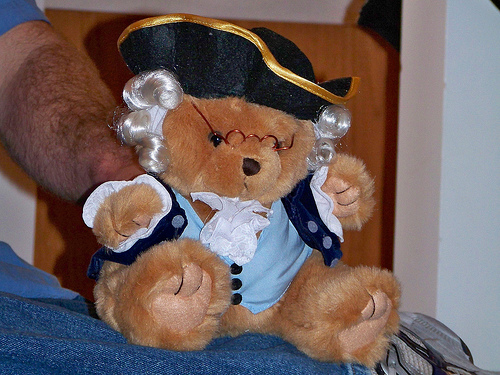<image>
Can you confirm if the bear is next to the man? Yes. The bear is positioned adjacent to the man, located nearby in the same general area. 